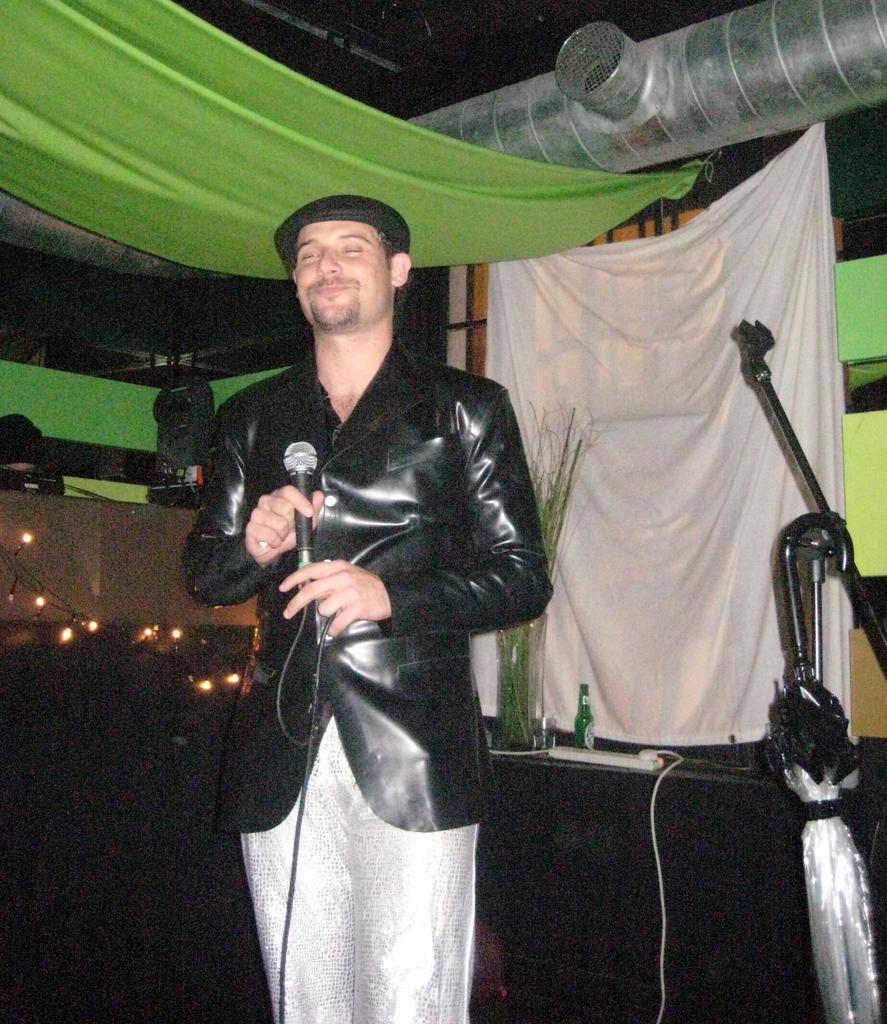How would you summarize this image in a sentence or two? In this image in the center there is one person who is standing, and he is holding a mike. And in the background there is wall, clothes, table, bottle, plants, umbrella, sticks, light and some objects. 